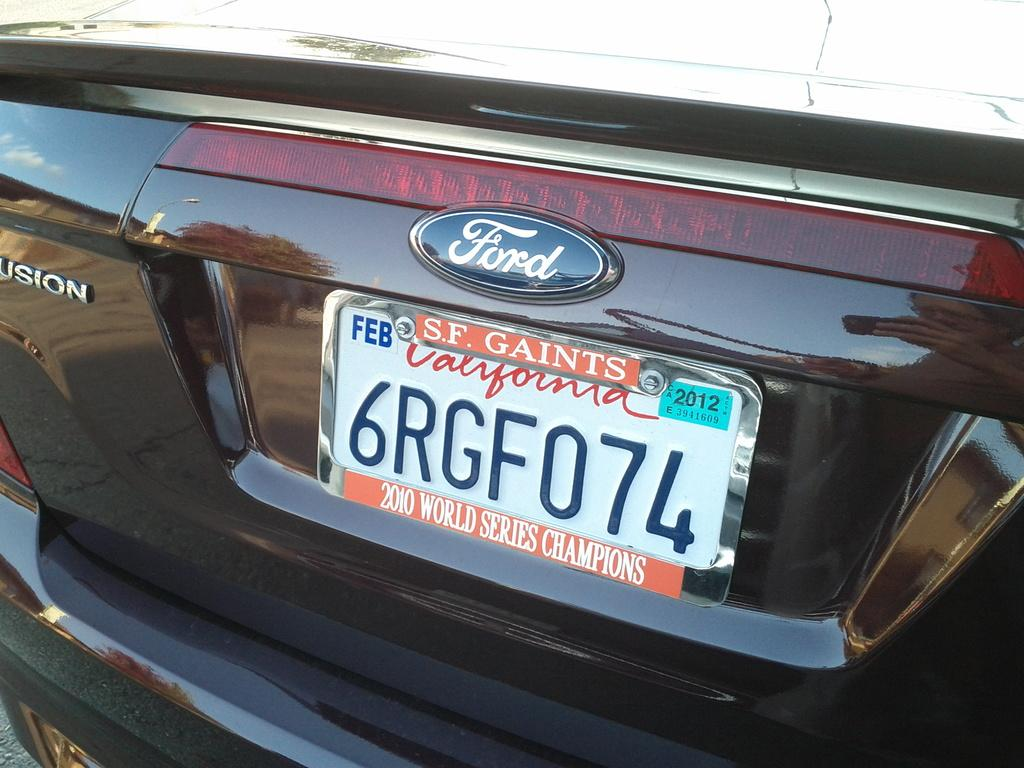<image>
Render a clear and concise summary of the photo. A ford fusion car with a San Francisco Giants license plate. 